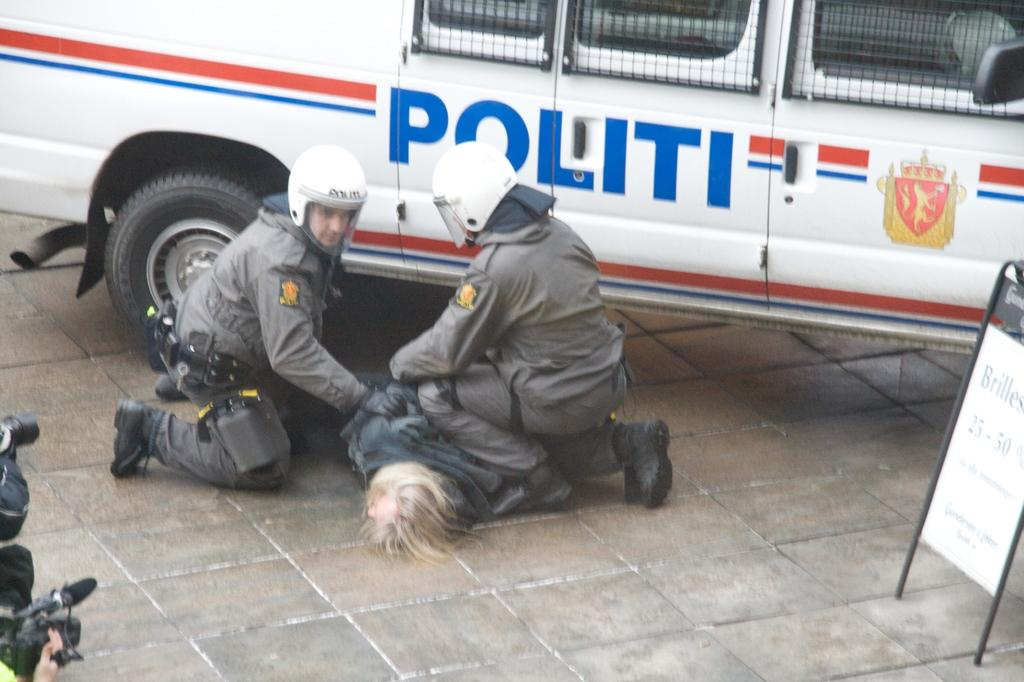<image>
Share a concise interpretation of the image provided. Police apprehend a man near a vehicle that says Politi on the side. 